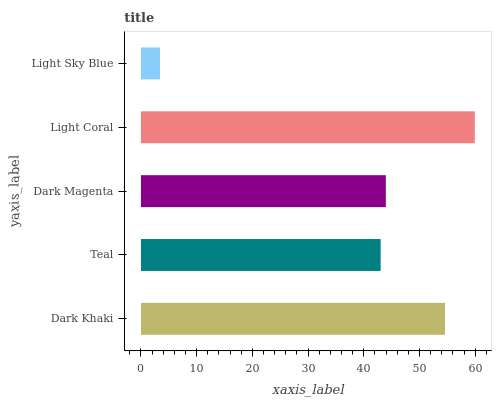Is Light Sky Blue the minimum?
Answer yes or no. Yes. Is Light Coral the maximum?
Answer yes or no. Yes. Is Teal the minimum?
Answer yes or no. No. Is Teal the maximum?
Answer yes or no. No. Is Dark Khaki greater than Teal?
Answer yes or no. Yes. Is Teal less than Dark Khaki?
Answer yes or no. Yes. Is Teal greater than Dark Khaki?
Answer yes or no. No. Is Dark Khaki less than Teal?
Answer yes or no. No. Is Dark Magenta the high median?
Answer yes or no. Yes. Is Dark Magenta the low median?
Answer yes or no. Yes. Is Teal the high median?
Answer yes or no. No. Is Teal the low median?
Answer yes or no. No. 